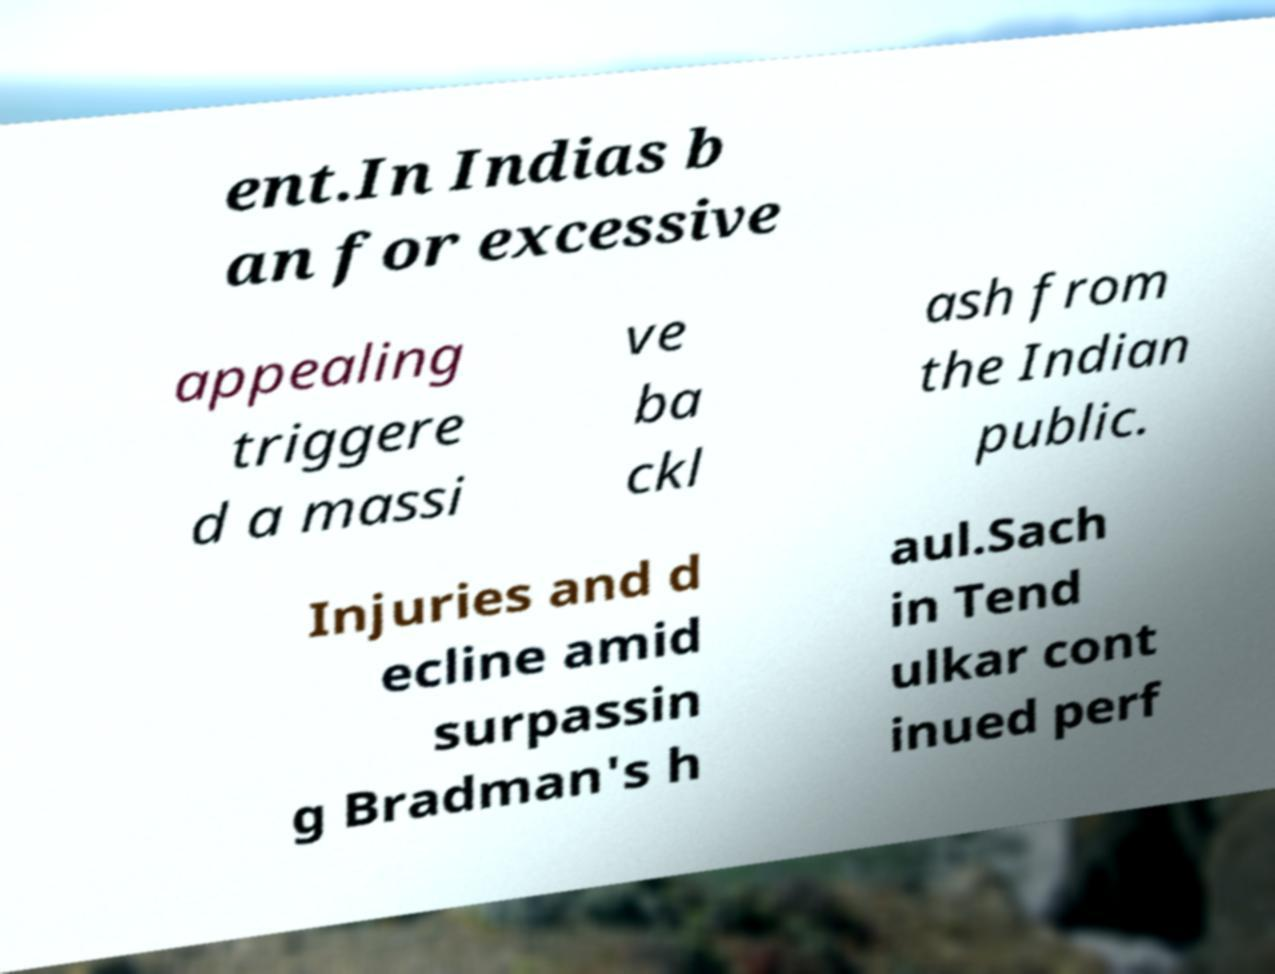Can you accurately transcribe the text from the provided image for me? ent.In Indias b an for excessive appealing triggere d a massi ve ba ckl ash from the Indian public. Injuries and d ecline amid surpassin g Bradman's h aul.Sach in Tend ulkar cont inued perf 